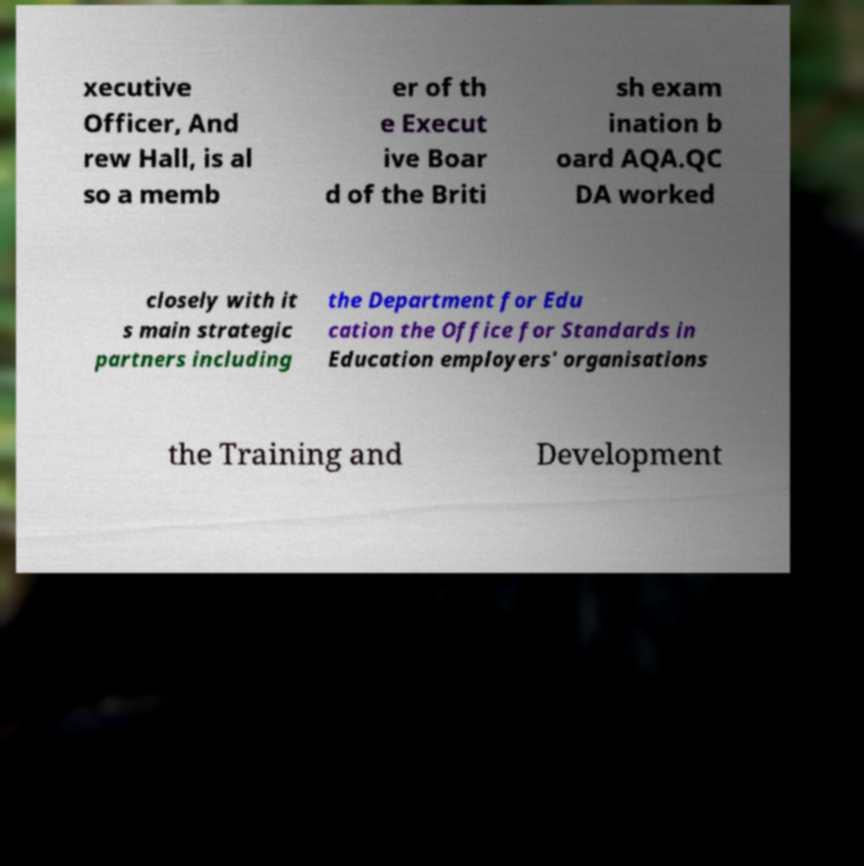Please identify and transcribe the text found in this image. xecutive Officer, And rew Hall, is al so a memb er of th e Execut ive Boar d of the Briti sh exam ination b oard AQA.QC DA worked closely with it s main strategic partners including the Department for Edu cation the Office for Standards in Education employers' organisations the Training and Development 